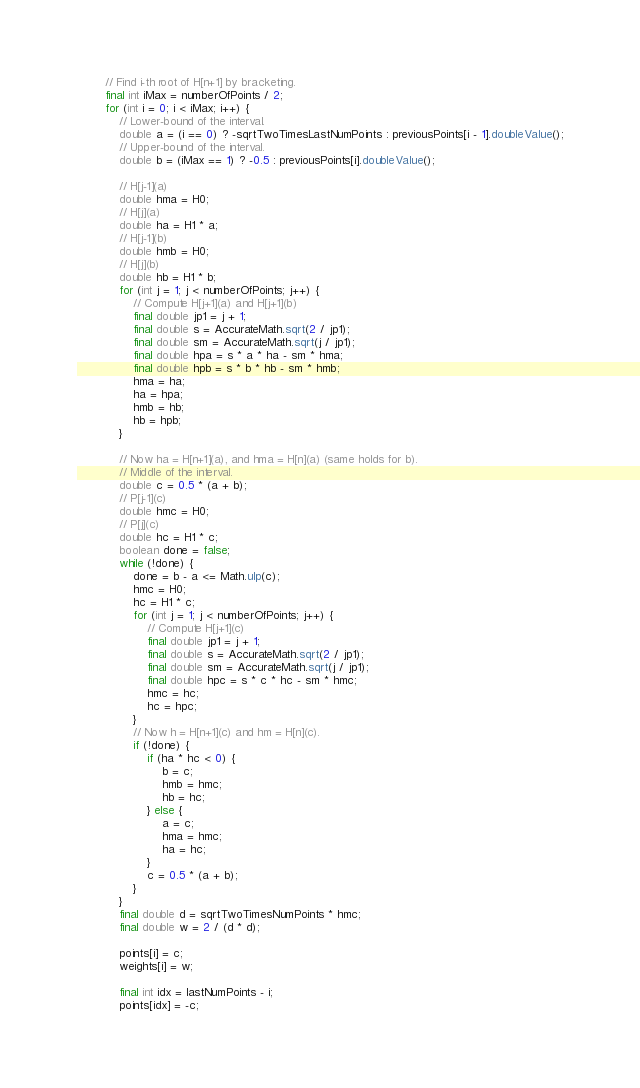Convert code to text. <code><loc_0><loc_0><loc_500><loc_500><_Java_>        // Find i-th root of H[n+1] by bracketing.
        final int iMax = numberOfPoints / 2;
        for (int i = 0; i < iMax; i++) {
            // Lower-bound of the interval.
            double a = (i == 0) ? -sqrtTwoTimesLastNumPoints : previousPoints[i - 1].doubleValue();
            // Upper-bound of the interval.
            double b = (iMax == 1) ? -0.5 : previousPoints[i].doubleValue();

            // H[j-1](a)
            double hma = H0;
            // H[j](a)
            double ha = H1 * a;
            // H[j-1](b)
            double hmb = H0;
            // H[j](b)
            double hb = H1 * b;
            for (int j = 1; j < numberOfPoints; j++) {
                // Compute H[j+1](a) and H[j+1](b)
                final double jp1 = j + 1;
                final double s = AccurateMath.sqrt(2 / jp1);
                final double sm = AccurateMath.sqrt(j / jp1);
                final double hpa = s * a * ha - sm * hma;
                final double hpb = s * b * hb - sm * hmb;
                hma = ha;
                ha = hpa;
                hmb = hb;
                hb = hpb;
            }

            // Now ha = H[n+1](a), and hma = H[n](a) (same holds for b).
            // Middle of the interval.
            double c = 0.5 * (a + b);
            // P[j-1](c)
            double hmc = H0;
            // P[j](c)
            double hc = H1 * c;
            boolean done = false;
            while (!done) {
                done = b - a <= Math.ulp(c);
                hmc = H0;
                hc = H1 * c;
                for (int j = 1; j < numberOfPoints; j++) {
                    // Compute H[j+1](c)
                    final double jp1 = j + 1;
                    final double s = AccurateMath.sqrt(2 / jp1);
                    final double sm = AccurateMath.sqrt(j / jp1);
                    final double hpc = s * c * hc - sm * hmc;
                    hmc = hc;
                    hc = hpc;
                }
                // Now h = H[n+1](c) and hm = H[n](c).
                if (!done) {
                    if (ha * hc < 0) {
                        b = c;
                        hmb = hmc;
                        hb = hc;
                    } else {
                        a = c;
                        hma = hmc;
                        ha = hc;
                    }
                    c = 0.5 * (a + b);
                }
            }
            final double d = sqrtTwoTimesNumPoints * hmc;
            final double w = 2 / (d * d);

            points[i] = c;
            weights[i] = w;

            final int idx = lastNumPoints - i;
            points[idx] = -c;</code> 